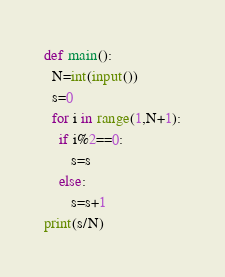<code> <loc_0><loc_0><loc_500><loc_500><_Python_>def main():
  N=int(input())
  s=0
  for i in range(1,N+1):
    if i%2==0:
       s=s
    else:
       s=s+1
print(s/N)</code> 